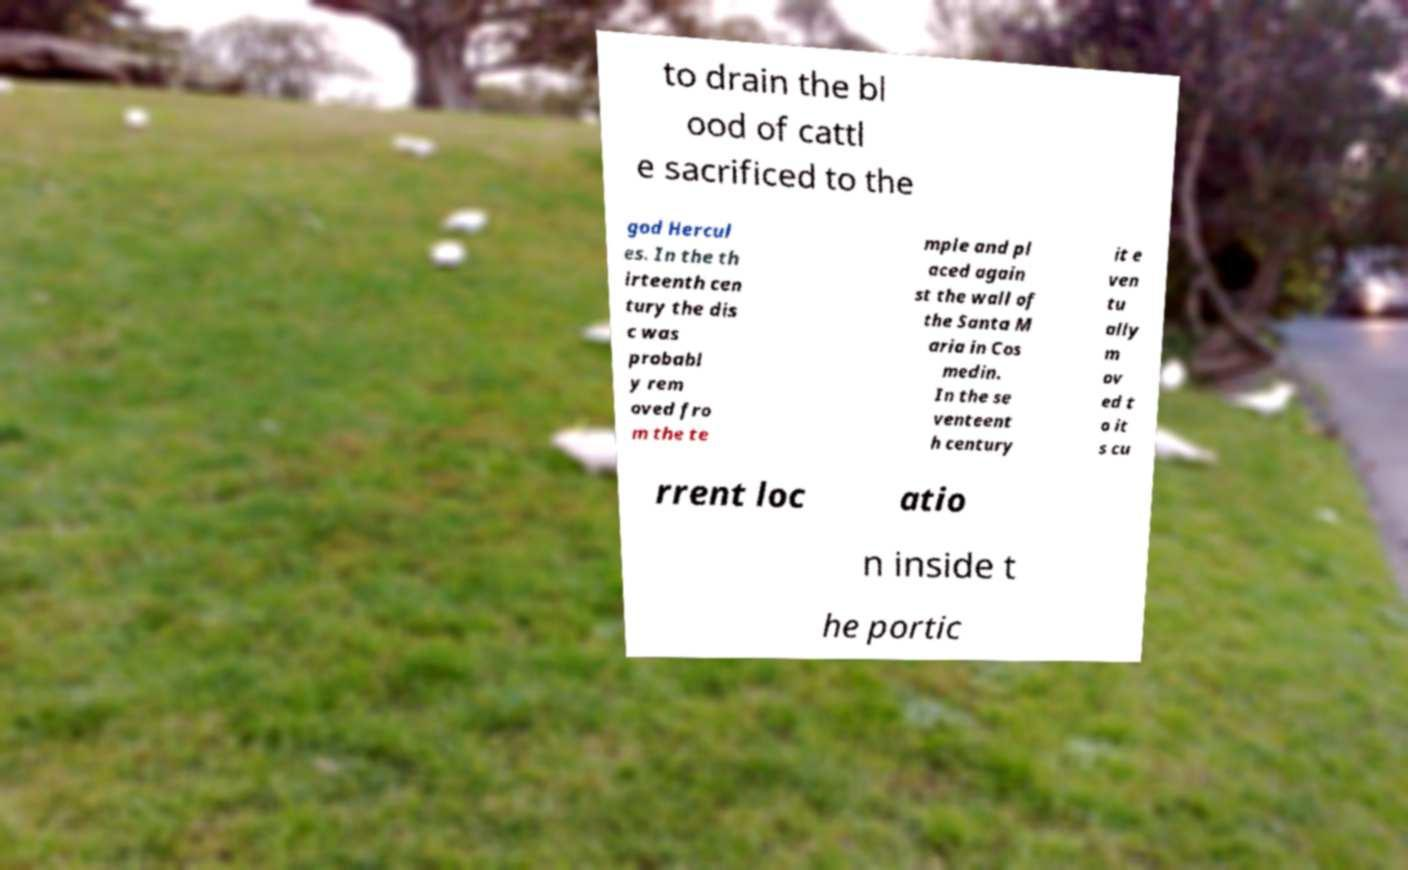Can you read and provide the text displayed in the image?This photo seems to have some interesting text. Can you extract and type it out for me? to drain the bl ood of cattl e sacrificed to the god Hercul es. In the th irteenth cen tury the dis c was probabl y rem oved fro m the te mple and pl aced again st the wall of the Santa M aria in Cos medin. In the se venteent h century it e ven tu ally m ov ed t o it s cu rrent loc atio n inside t he portic 